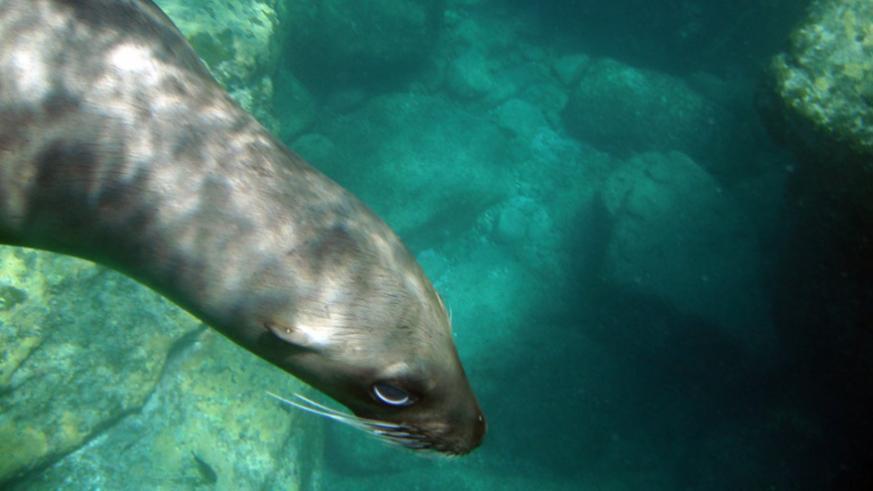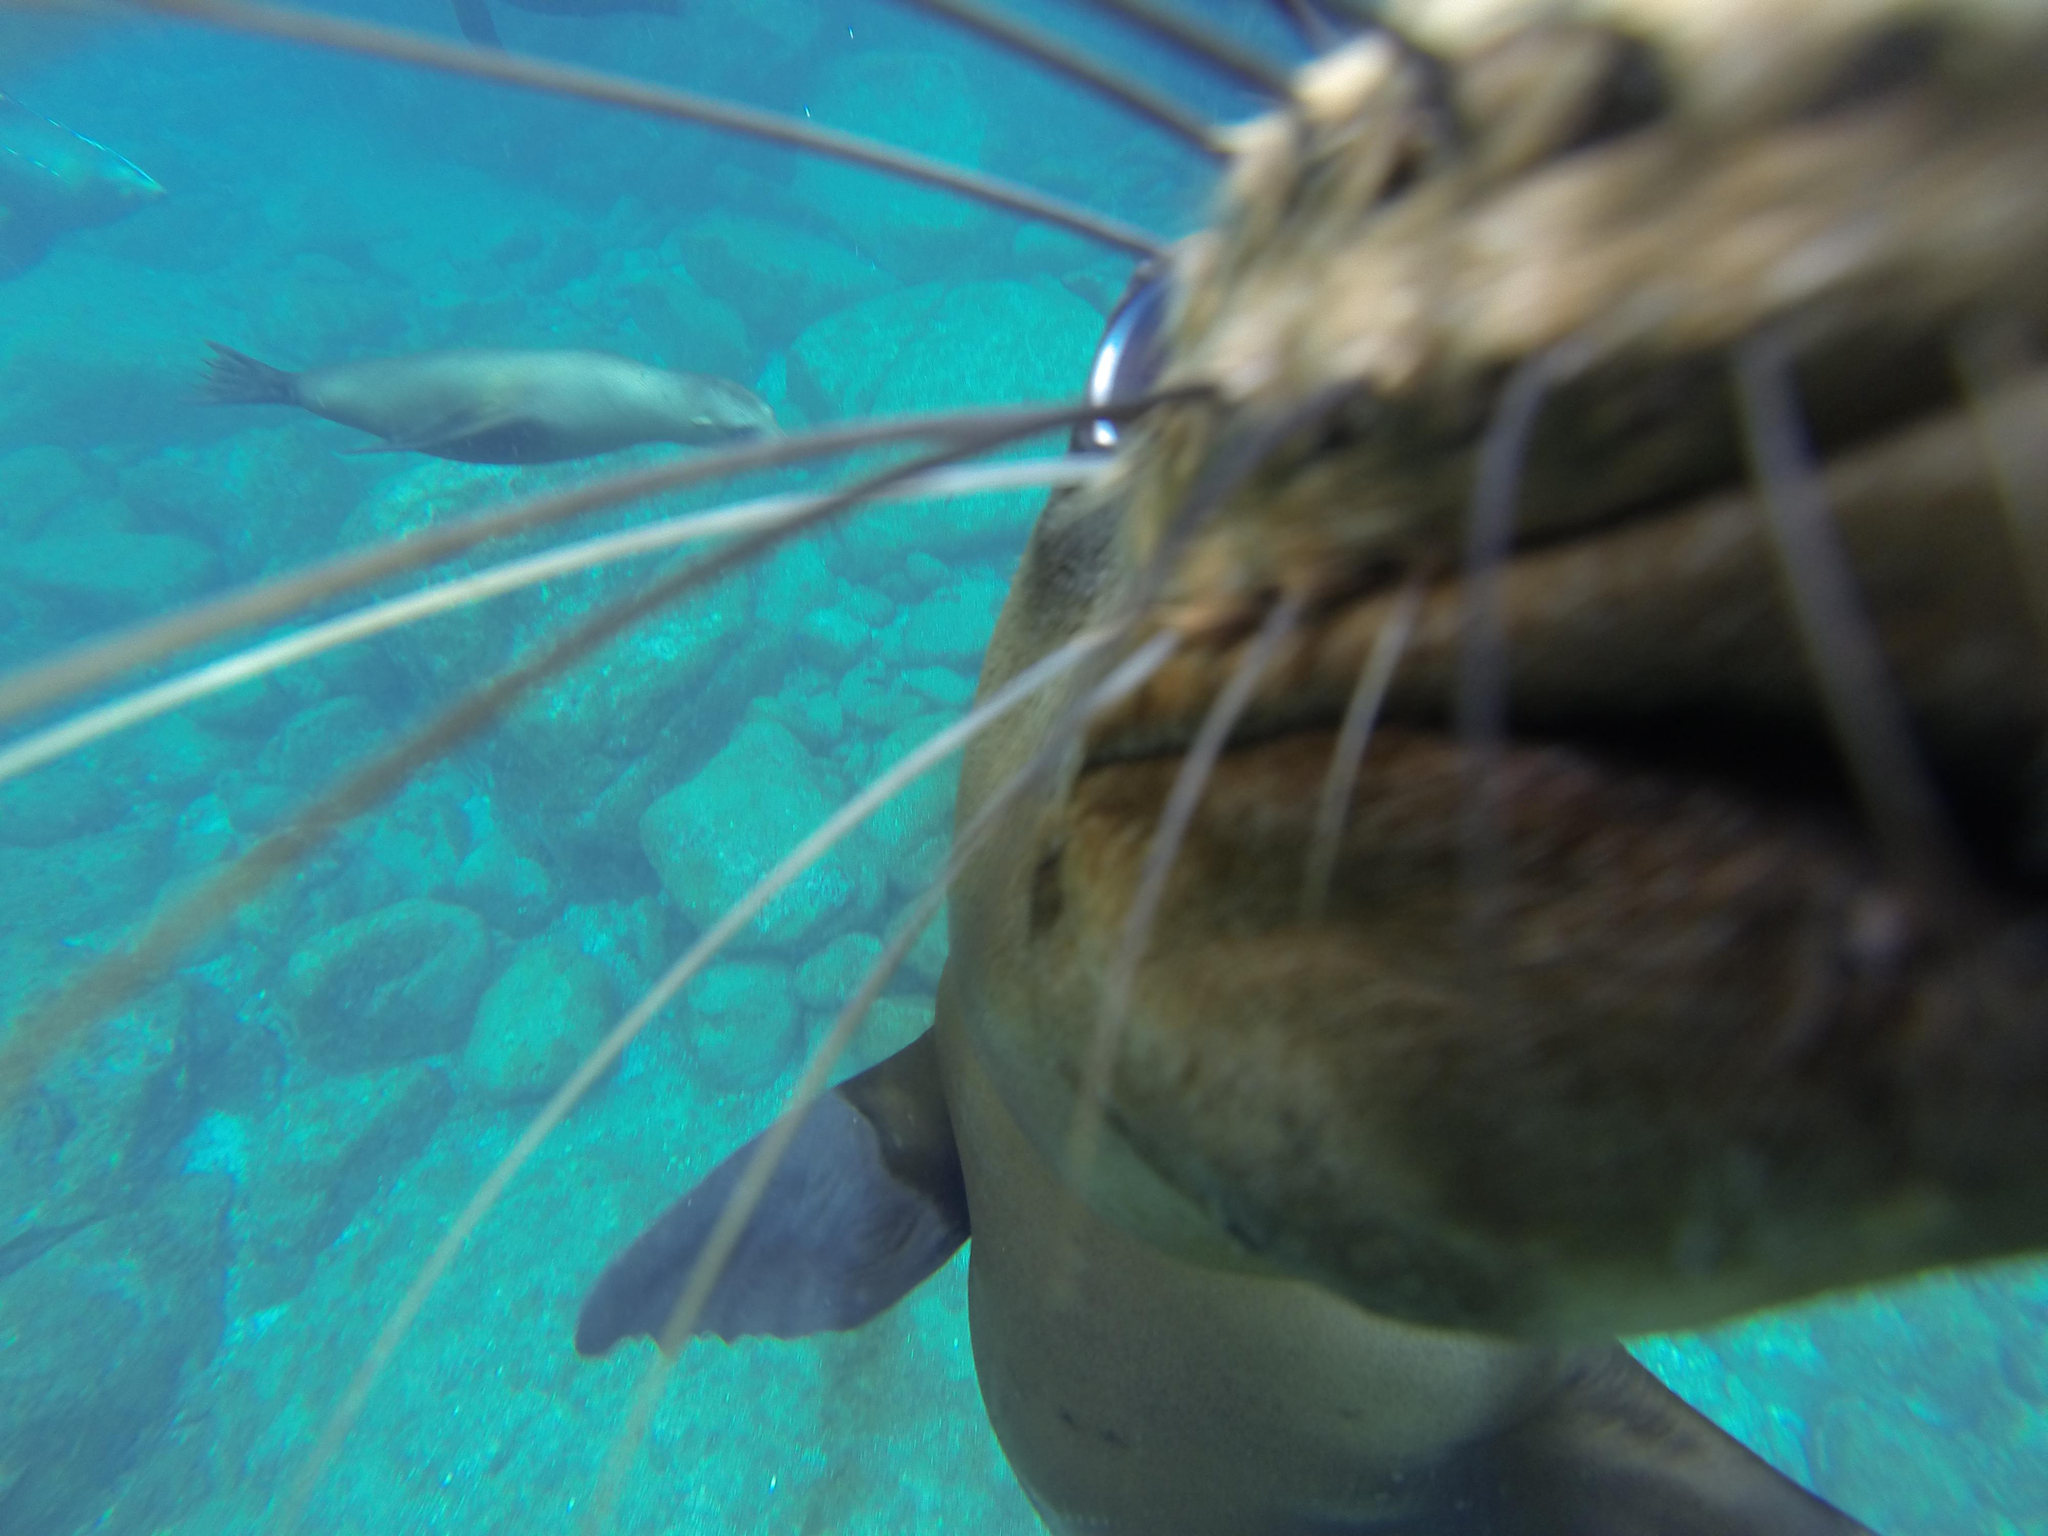The first image is the image on the left, the second image is the image on the right. Considering the images on both sides, is "An image of an otter underwater includes a scuba diver." valid? Answer yes or no. No. The first image is the image on the left, the second image is the image on the right. Examine the images to the left and right. Is the description "A diver is swimming near a sea animal." accurate? Answer yes or no. No. 